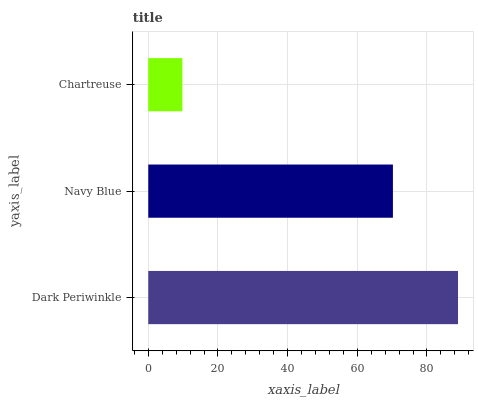Is Chartreuse the minimum?
Answer yes or no. Yes. Is Dark Periwinkle the maximum?
Answer yes or no. Yes. Is Navy Blue the minimum?
Answer yes or no. No. Is Navy Blue the maximum?
Answer yes or no. No. Is Dark Periwinkle greater than Navy Blue?
Answer yes or no. Yes. Is Navy Blue less than Dark Periwinkle?
Answer yes or no. Yes. Is Navy Blue greater than Dark Periwinkle?
Answer yes or no. No. Is Dark Periwinkle less than Navy Blue?
Answer yes or no. No. Is Navy Blue the high median?
Answer yes or no. Yes. Is Navy Blue the low median?
Answer yes or no. Yes. Is Chartreuse the high median?
Answer yes or no. No. Is Dark Periwinkle the low median?
Answer yes or no. No. 